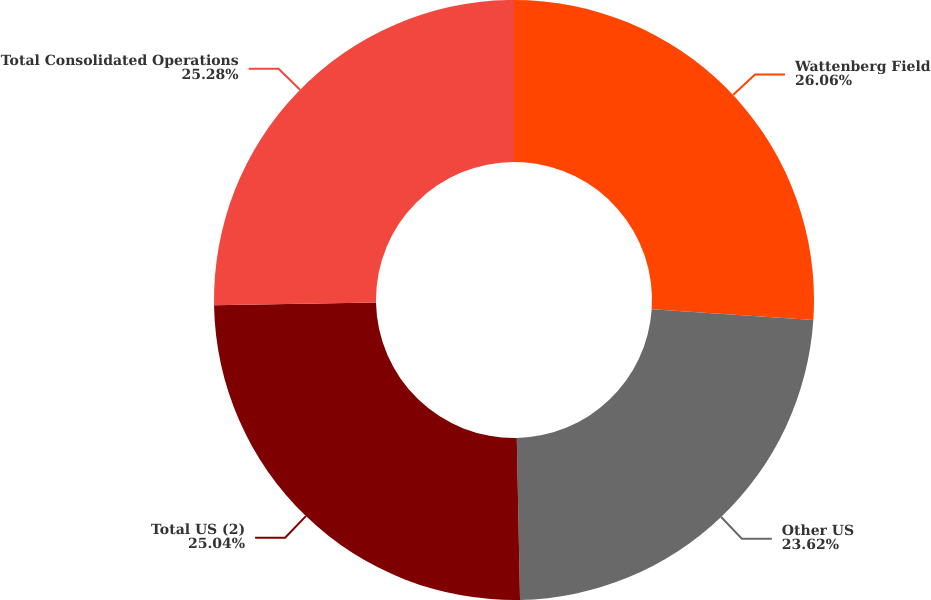<chart> <loc_0><loc_0><loc_500><loc_500><pie_chart><fcel>Wattenberg Field<fcel>Other US<fcel>Total US (2)<fcel>Total Consolidated Operations<nl><fcel>26.06%<fcel>23.62%<fcel>25.04%<fcel>25.28%<nl></chart> 